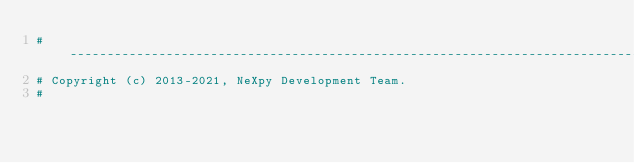<code> <loc_0><loc_0><loc_500><loc_500><_Python_># -----------------------------------------------------------------------------
# Copyright (c) 2013-2021, NeXpy Development Team.
#</code> 